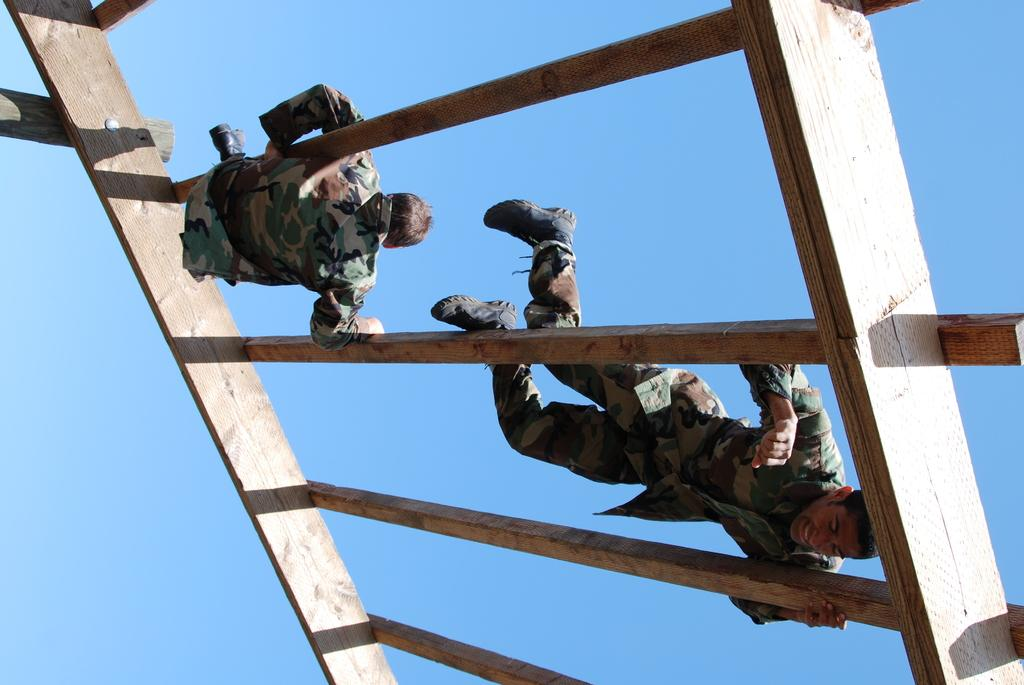How many people are in the image? There are two persons in the image. What are the persons standing on? The persons are on a wooden material. What can be seen in the background of the image? The sky is visible in the background of the image. What type of fish can be seen swimming in the wooden material in the image? There are no fish present in the image; the wooden material is being used ascertained by the two persons. 